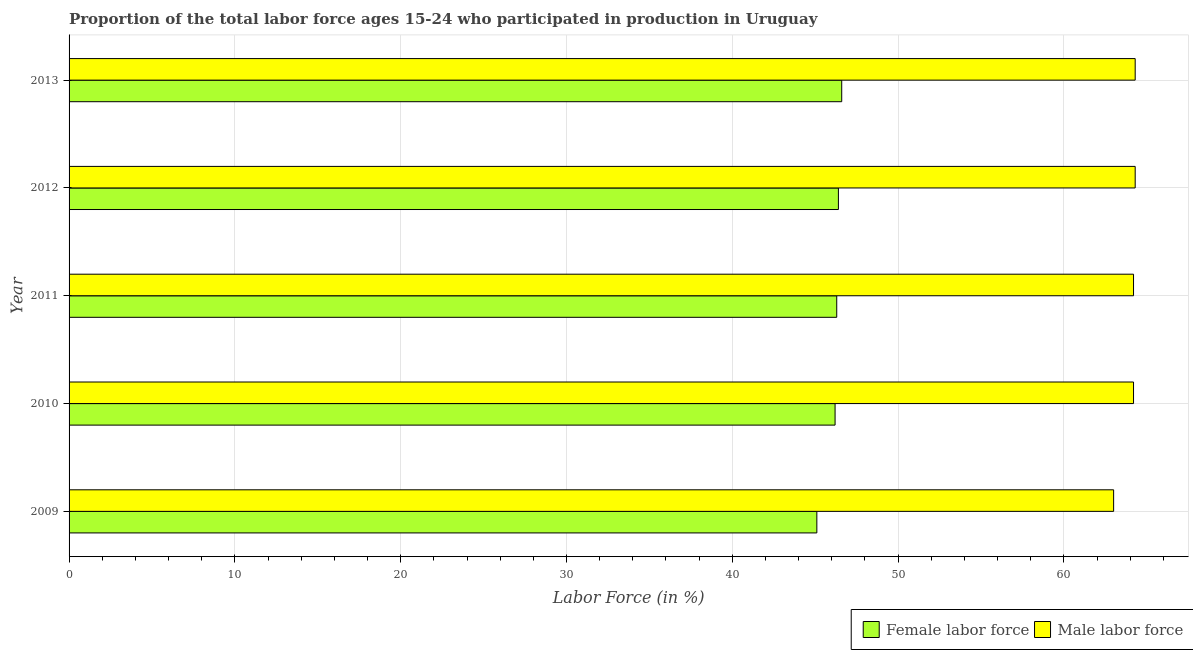How many groups of bars are there?
Offer a very short reply. 5. How many bars are there on the 5th tick from the top?
Offer a very short reply. 2. How many bars are there on the 1st tick from the bottom?
Offer a terse response. 2. What is the label of the 2nd group of bars from the top?
Provide a succinct answer. 2012. In how many cases, is the number of bars for a given year not equal to the number of legend labels?
Make the answer very short. 0. What is the percentage of male labour force in 2011?
Keep it short and to the point. 64.2. Across all years, what is the maximum percentage of female labor force?
Your answer should be compact. 46.6. Across all years, what is the minimum percentage of male labour force?
Offer a very short reply. 63. What is the total percentage of male labour force in the graph?
Your answer should be very brief. 320. What is the difference between the percentage of male labour force in 2011 and the percentage of female labor force in 2010?
Offer a terse response. 18. What is the average percentage of female labor force per year?
Ensure brevity in your answer.  46.12. In the year 2012, what is the difference between the percentage of female labor force and percentage of male labour force?
Keep it short and to the point. -17.9. What is the ratio of the percentage of male labour force in 2012 to that in 2013?
Offer a very short reply. 1. What is the difference between the highest and the second highest percentage of male labour force?
Offer a very short reply. 0. What does the 2nd bar from the top in 2010 represents?
Your response must be concise. Female labor force. What does the 2nd bar from the bottom in 2012 represents?
Your answer should be compact. Male labor force. How many bars are there?
Keep it short and to the point. 10. How many years are there in the graph?
Give a very brief answer. 5. What is the difference between two consecutive major ticks on the X-axis?
Make the answer very short. 10. Does the graph contain any zero values?
Your answer should be compact. No. Does the graph contain grids?
Offer a very short reply. Yes. Where does the legend appear in the graph?
Keep it short and to the point. Bottom right. What is the title of the graph?
Provide a succinct answer. Proportion of the total labor force ages 15-24 who participated in production in Uruguay. What is the label or title of the X-axis?
Your answer should be very brief. Labor Force (in %). What is the label or title of the Y-axis?
Give a very brief answer. Year. What is the Labor Force (in %) in Female labor force in 2009?
Offer a terse response. 45.1. What is the Labor Force (in %) of Female labor force in 2010?
Ensure brevity in your answer.  46.2. What is the Labor Force (in %) of Male labor force in 2010?
Provide a succinct answer. 64.2. What is the Labor Force (in %) of Female labor force in 2011?
Ensure brevity in your answer.  46.3. What is the Labor Force (in %) of Male labor force in 2011?
Offer a very short reply. 64.2. What is the Labor Force (in %) in Female labor force in 2012?
Your response must be concise. 46.4. What is the Labor Force (in %) of Male labor force in 2012?
Ensure brevity in your answer.  64.3. What is the Labor Force (in %) in Female labor force in 2013?
Ensure brevity in your answer.  46.6. What is the Labor Force (in %) in Male labor force in 2013?
Offer a terse response. 64.3. Across all years, what is the maximum Labor Force (in %) of Female labor force?
Your answer should be compact. 46.6. Across all years, what is the maximum Labor Force (in %) of Male labor force?
Provide a succinct answer. 64.3. Across all years, what is the minimum Labor Force (in %) in Female labor force?
Keep it short and to the point. 45.1. What is the total Labor Force (in %) of Female labor force in the graph?
Provide a succinct answer. 230.6. What is the total Labor Force (in %) of Male labor force in the graph?
Provide a succinct answer. 320. What is the difference between the Labor Force (in %) in Male labor force in 2009 and that in 2011?
Offer a very short reply. -1.2. What is the difference between the Labor Force (in %) of Male labor force in 2009 and that in 2012?
Provide a succinct answer. -1.3. What is the difference between the Labor Force (in %) of Male labor force in 2009 and that in 2013?
Provide a short and direct response. -1.3. What is the difference between the Labor Force (in %) of Female labor force in 2010 and that in 2011?
Provide a short and direct response. -0.1. What is the difference between the Labor Force (in %) in Male labor force in 2010 and that in 2011?
Your answer should be very brief. 0. What is the difference between the Labor Force (in %) in Male labor force in 2010 and that in 2012?
Offer a very short reply. -0.1. What is the difference between the Labor Force (in %) in Female labor force in 2010 and that in 2013?
Your answer should be compact. -0.4. What is the difference between the Labor Force (in %) in Female labor force in 2011 and that in 2012?
Your response must be concise. -0.1. What is the difference between the Labor Force (in %) in Male labor force in 2011 and that in 2012?
Keep it short and to the point. -0.1. What is the difference between the Labor Force (in %) of Female labor force in 2011 and that in 2013?
Your answer should be very brief. -0.3. What is the difference between the Labor Force (in %) of Female labor force in 2012 and that in 2013?
Ensure brevity in your answer.  -0.2. What is the difference between the Labor Force (in %) in Male labor force in 2012 and that in 2013?
Give a very brief answer. 0. What is the difference between the Labor Force (in %) in Female labor force in 2009 and the Labor Force (in %) in Male labor force in 2010?
Offer a very short reply. -19.1. What is the difference between the Labor Force (in %) in Female labor force in 2009 and the Labor Force (in %) in Male labor force in 2011?
Your answer should be compact. -19.1. What is the difference between the Labor Force (in %) in Female labor force in 2009 and the Labor Force (in %) in Male labor force in 2012?
Give a very brief answer. -19.2. What is the difference between the Labor Force (in %) of Female labor force in 2009 and the Labor Force (in %) of Male labor force in 2013?
Your response must be concise. -19.2. What is the difference between the Labor Force (in %) of Female labor force in 2010 and the Labor Force (in %) of Male labor force in 2012?
Your answer should be very brief. -18.1. What is the difference between the Labor Force (in %) in Female labor force in 2010 and the Labor Force (in %) in Male labor force in 2013?
Provide a short and direct response. -18.1. What is the difference between the Labor Force (in %) in Female labor force in 2011 and the Labor Force (in %) in Male labor force in 2012?
Your answer should be very brief. -18. What is the difference between the Labor Force (in %) of Female labor force in 2011 and the Labor Force (in %) of Male labor force in 2013?
Your answer should be compact. -18. What is the difference between the Labor Force (in %) in Female labor force in 2012 and the Labor Force (in %) in Male labor force in 2013?
Offer a very short reply. -17.9. What is the average Labor Force (in %) of Female labor force per year?
Give a very brief answer. 46.12. In the year 2009, what is the difference between the Labor Force (in %) of Female labor force and Labor Force (in %) of Male labor force?
Give a very brief answer. -17.9. In the year 2011, what is the difference between the Labor Force (in %) of Female labor force and Labor Force (in %) of Male labor force?
Your answer should be compact. -17.9. In the year 2012, what is the difference between the Labor Force (in %) of Female labor force and Labor Force (in %) of Male labor force?
Provide a short and direct response. -17.9. In the year 2013, what is the difference between the Labor Force (in %) of Female labor force and Labor Force (in %) of Male labor force?
Keep it short and to the point. -17.7. What is the ratio of the Labor Force (in %) in Female labor force in 2009 to that in 2010?
Keep it short and to the point. 0.98. What is the ratio of the Labor Force (in %) in Male labor force in 2009 to that in 2010?
Ensure brevity in your answer.  0.98. What is the ratio of the Labor Force (in %) of Female labor force in 2009 to that in 2011?
Offer a terse response. 0.97. What is the ratio of the Labor Force (in %) of Male labor force in 2009 to that in 2011?
Your answer should be compact. 0.98. What is the ratio of the Labor Force (in %) in Male labor force in 2009 to that in 2012?
Offer a very short reply. 0.98. What is the ratio of the Labor Force (in %) in Female labor force in 2009 to that in 2013?
Your response must be concise. 0.97. What is the ratio of the Labor Force (in %) in Male labor force in 2009 to that in 2013?
Provide a short and direct response. 0.98. What is the ratio of the Labor Force (in %) of Female labor force in 2010 to that in 2012?
Your response must be concise. 1. What is the ratio of the Labor Force (in %) of Male labor force in 2010 to that in 2012?
Make the answer very short. 1. What is the ratio of the Labor Force (in %) in Female labor force in 2011 to that in 2012?
Your response must be concise. 1. What is the ratio of the Labor Force (in %) of Male labor force in 2011 to that in 2012?
Give a very brief answer. 1. What is the ratio of the Labor Force (in %) in Male labor force in 2011 to that in 2013?
Your answer should be compact. 1. What is the ratio of the Labor Force (in %) in Female labor force in 2012 to that in 2013?
Your answer should be compact. 1. What is the difference between the highest and the lowest Labor Force (in %) of Female labor force?
Keep it short and to the point. 1.5. What is the difference between the highest and the lowest Labor Force (in %) in Male labor force?
Your answer should be compact. 1.3. 